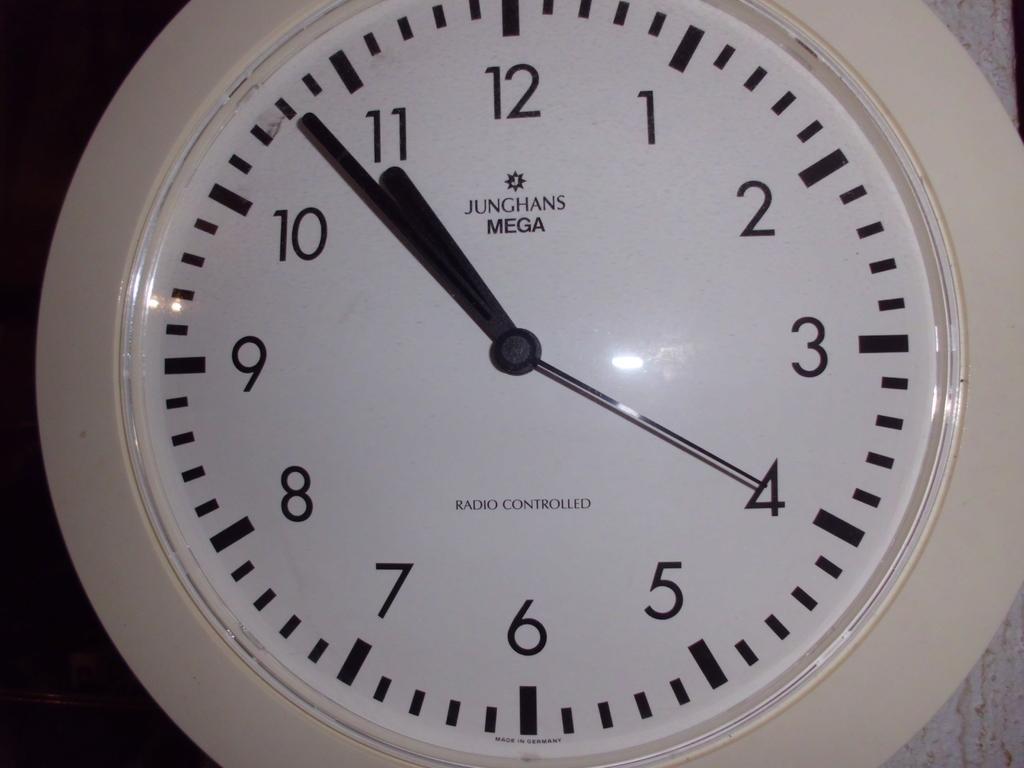<image>
Write a terse but informative summary of the picture. A white bordered Junghans mega branded clock with the time being 10:48. 